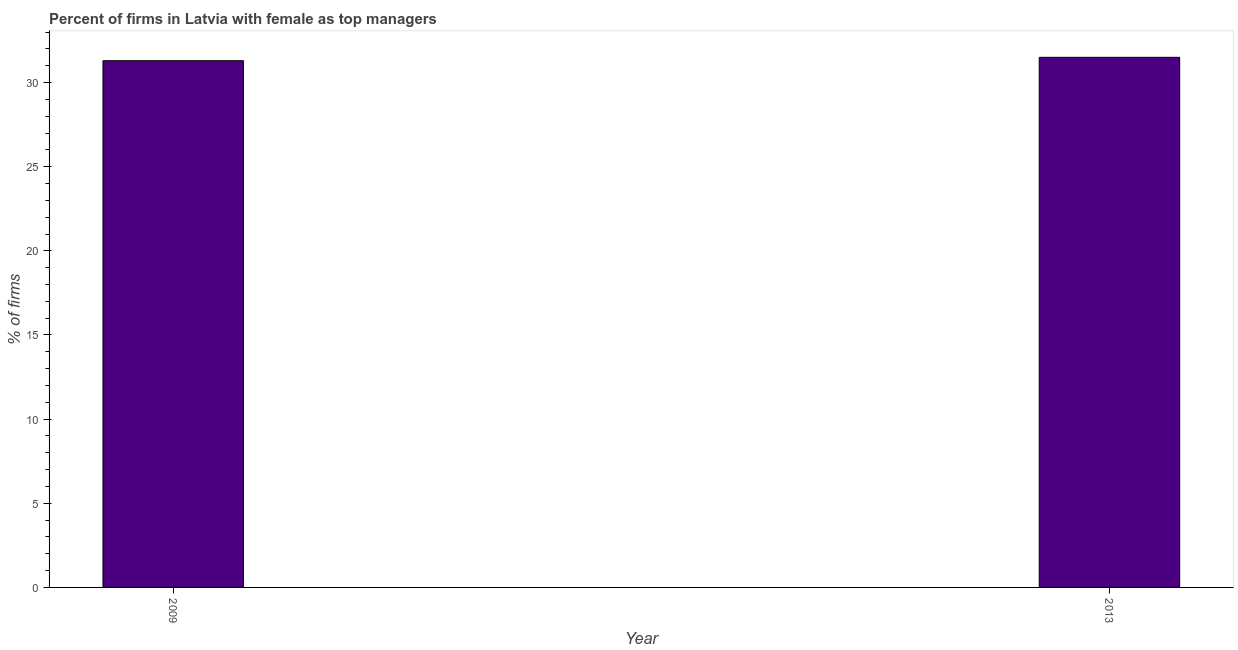Does the graph contain grids?
Make the answer very short. No. What is the title of the graph?
Provide a succinct answer. Percent of firms in Latvia with female as top managers. What is the label or title of the Y-axis?
Give a very brief answer. % of firms. What is the percentage of firms with female as top manager in 2009?
Keep it short and to the point. 31.3. Across all years, what is the maximum percentage of firms with female as top manager?
Your response must be concise. 31.5. Across all years, what is the minimum percentage of firms with female as top manager?
Make the answer very short. 31.3. In which year was the percentage of firms with female as top manager maximum?
Offer a terse response. 2013. In which year was the percentage of firms with female as top manager minimum?
Provide a short and direct response. 2009. What is the sum of the percentage of firms with female as top manager?
Provide a succinct answer. 62.8. What is the difference between the percentage of firms with female as top manager in 2009 and 2013?
Provide a succinct answer. -0.2. What is the average percentage of firms with female as top manager per year?
Offer a terse response. 31.4. What is the median percentage of firms with female as top manager?
Keep it short and to the point. 31.4. In how many years, is the percentage of firms with female as top manager greater than 1 %?
Keep it short and to the point. 2. What is the ratio of the percentage of firms with female as top manager in 2009 to that in 2013?
Give a very brief answer. 0.99. In how many years, is the percentage of firms with female as top manager greater than the average percentage of firms with female as top manager taken over all years?
Your answer should be compact. 1. How many bars are there?
Your answer should be very brief. 2. Are all the bars in the graph horizontal?
Offer a terse response. No. What is the difference between two consecutive major ticks on the Y-axis?
Ensure brevity in your answer.  5. Are the values on the major ticks of Y-axis written in scientific E-notation?
Provide a succinct answer. No. What is the % of firms of 2009?
Provide a succinct answer. 31.3. What is the % of firms of 2013?
Keep it short and to the point. 31.5. What is the difference between the % of firms in 2009 and 2013?
Your answer should be very brief. -0.2. What is the ratio of the % of firms in 2009 to that in 2013?
Provide a short and direct response. 0.99. 